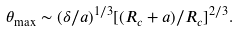Convert formula to latex. <formula><loc_0><loc_0><loc_500><loc_500>\theta _ { \max } \sim ( \delta / a ) ^ { 1 / 3 } [ ( R _ { c } + a ) / R _ { c } ] ^ { 2 / 3 } .</formula> 